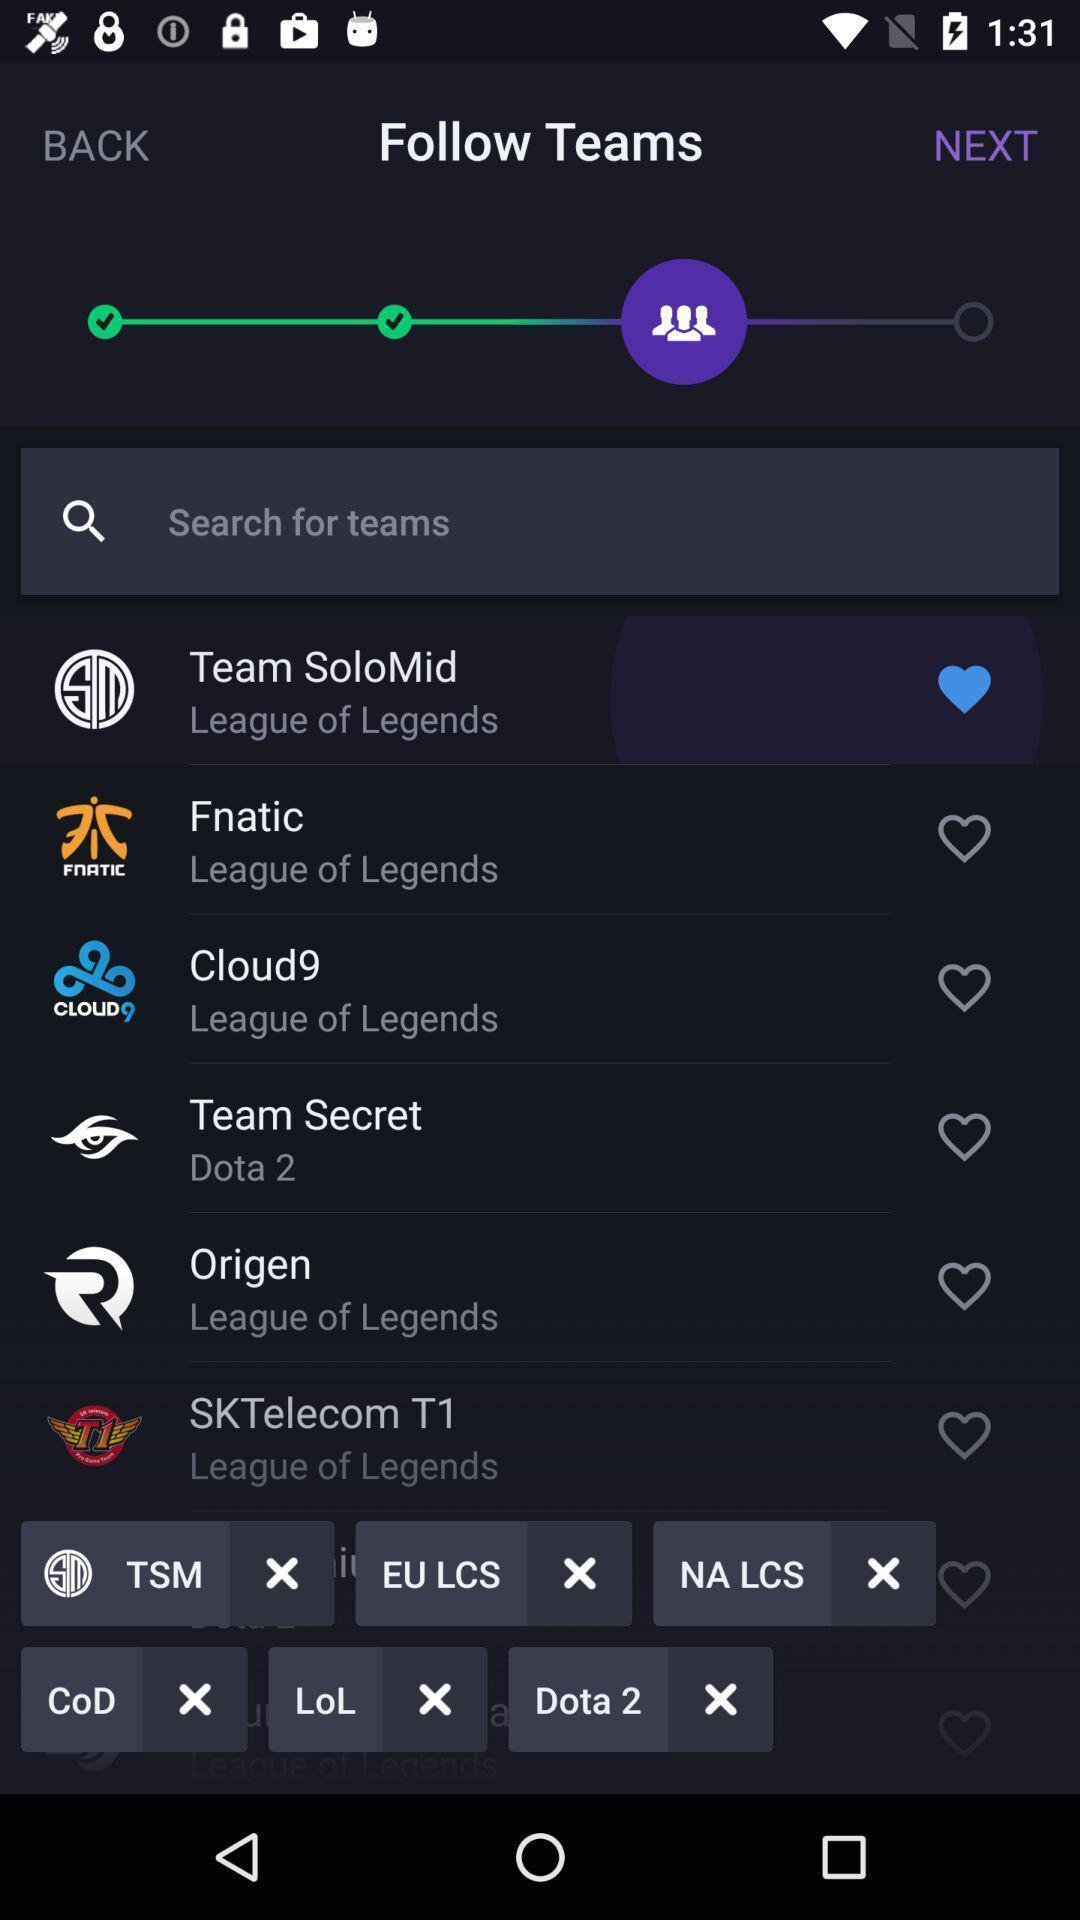Tell me what you see in this picture. Search bar for finding different teams. 